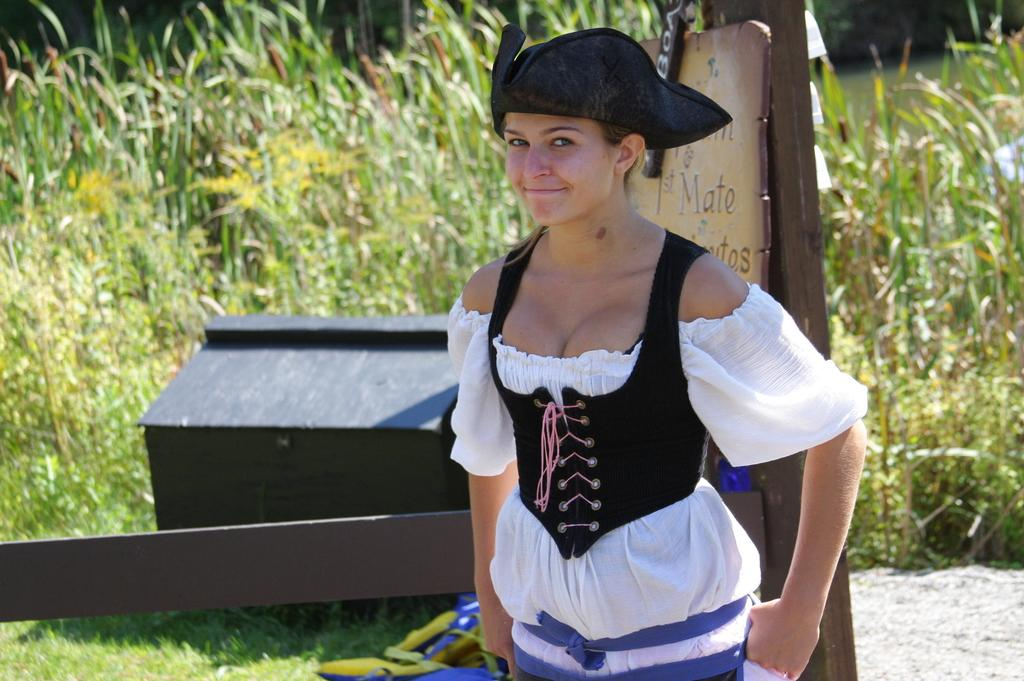<image>
Provide a brief description of the given image. A woman in a pirate outfit in front of a sign that says 1st Mate on it. 